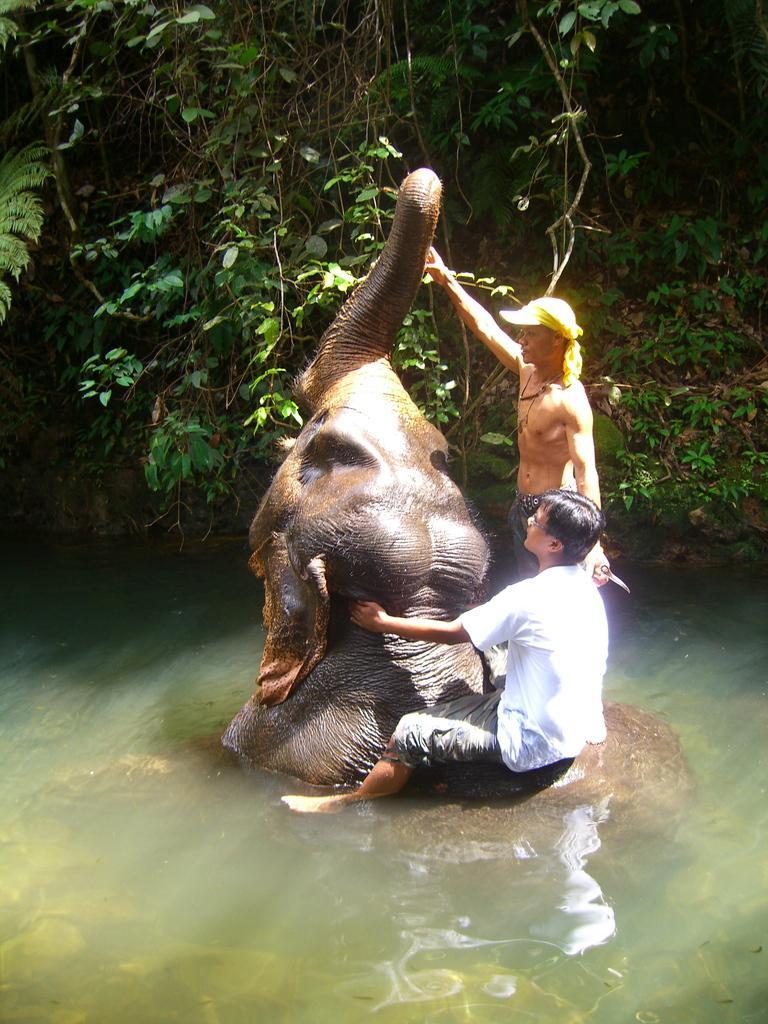In one or two sentences, can you explain what this image depicts? In this picture there is an elephant in a lake. There are two persons, one person sitting on it, another person standing on it and holding its trunk. In the background there are group of trees. 